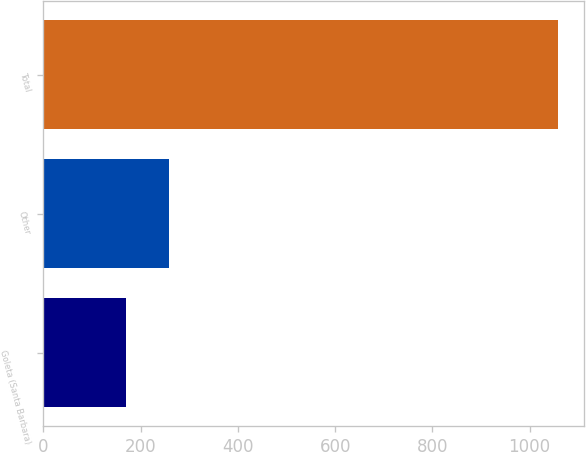Convert chart to OTSL. <chart><loc_0><loc_0><loc_500><loc_500><bar_chart><fcel>Goleta (Santa Barbara)<fcel>Other<fcel>Total<nl><fcel>169<fcel>257.9<fcel>1058<nl></chart> 